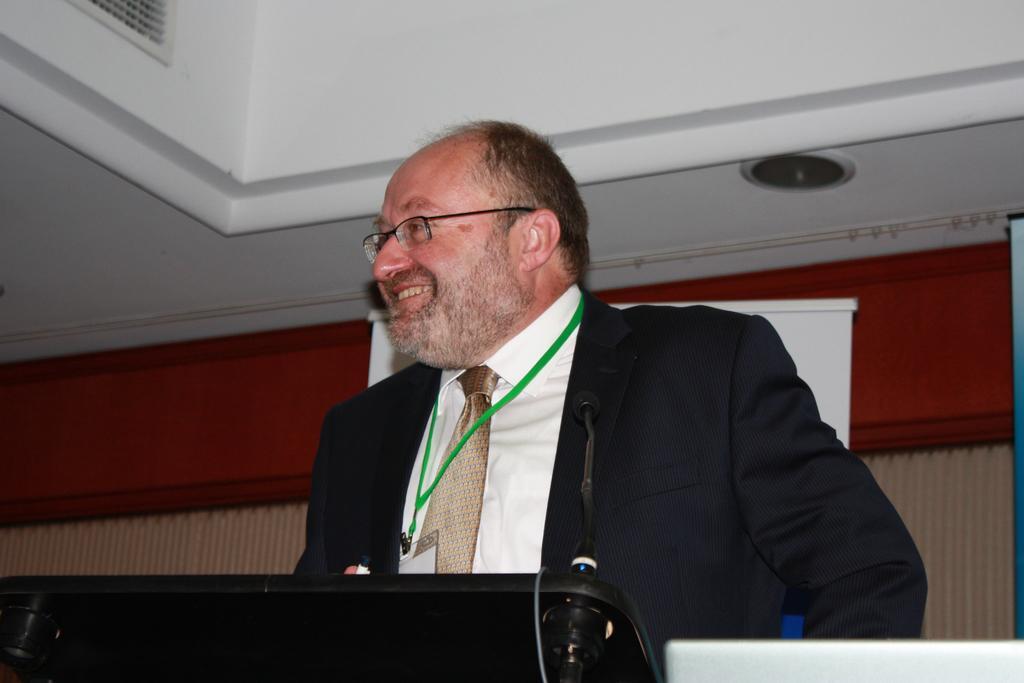Please provide a concise description of this image. In the middle of this image, there is a person in a suit smiling and standing in front of a stand. On the right side, there is a white colored object. In the background, there is a light attached to a roof and there is a wall. 